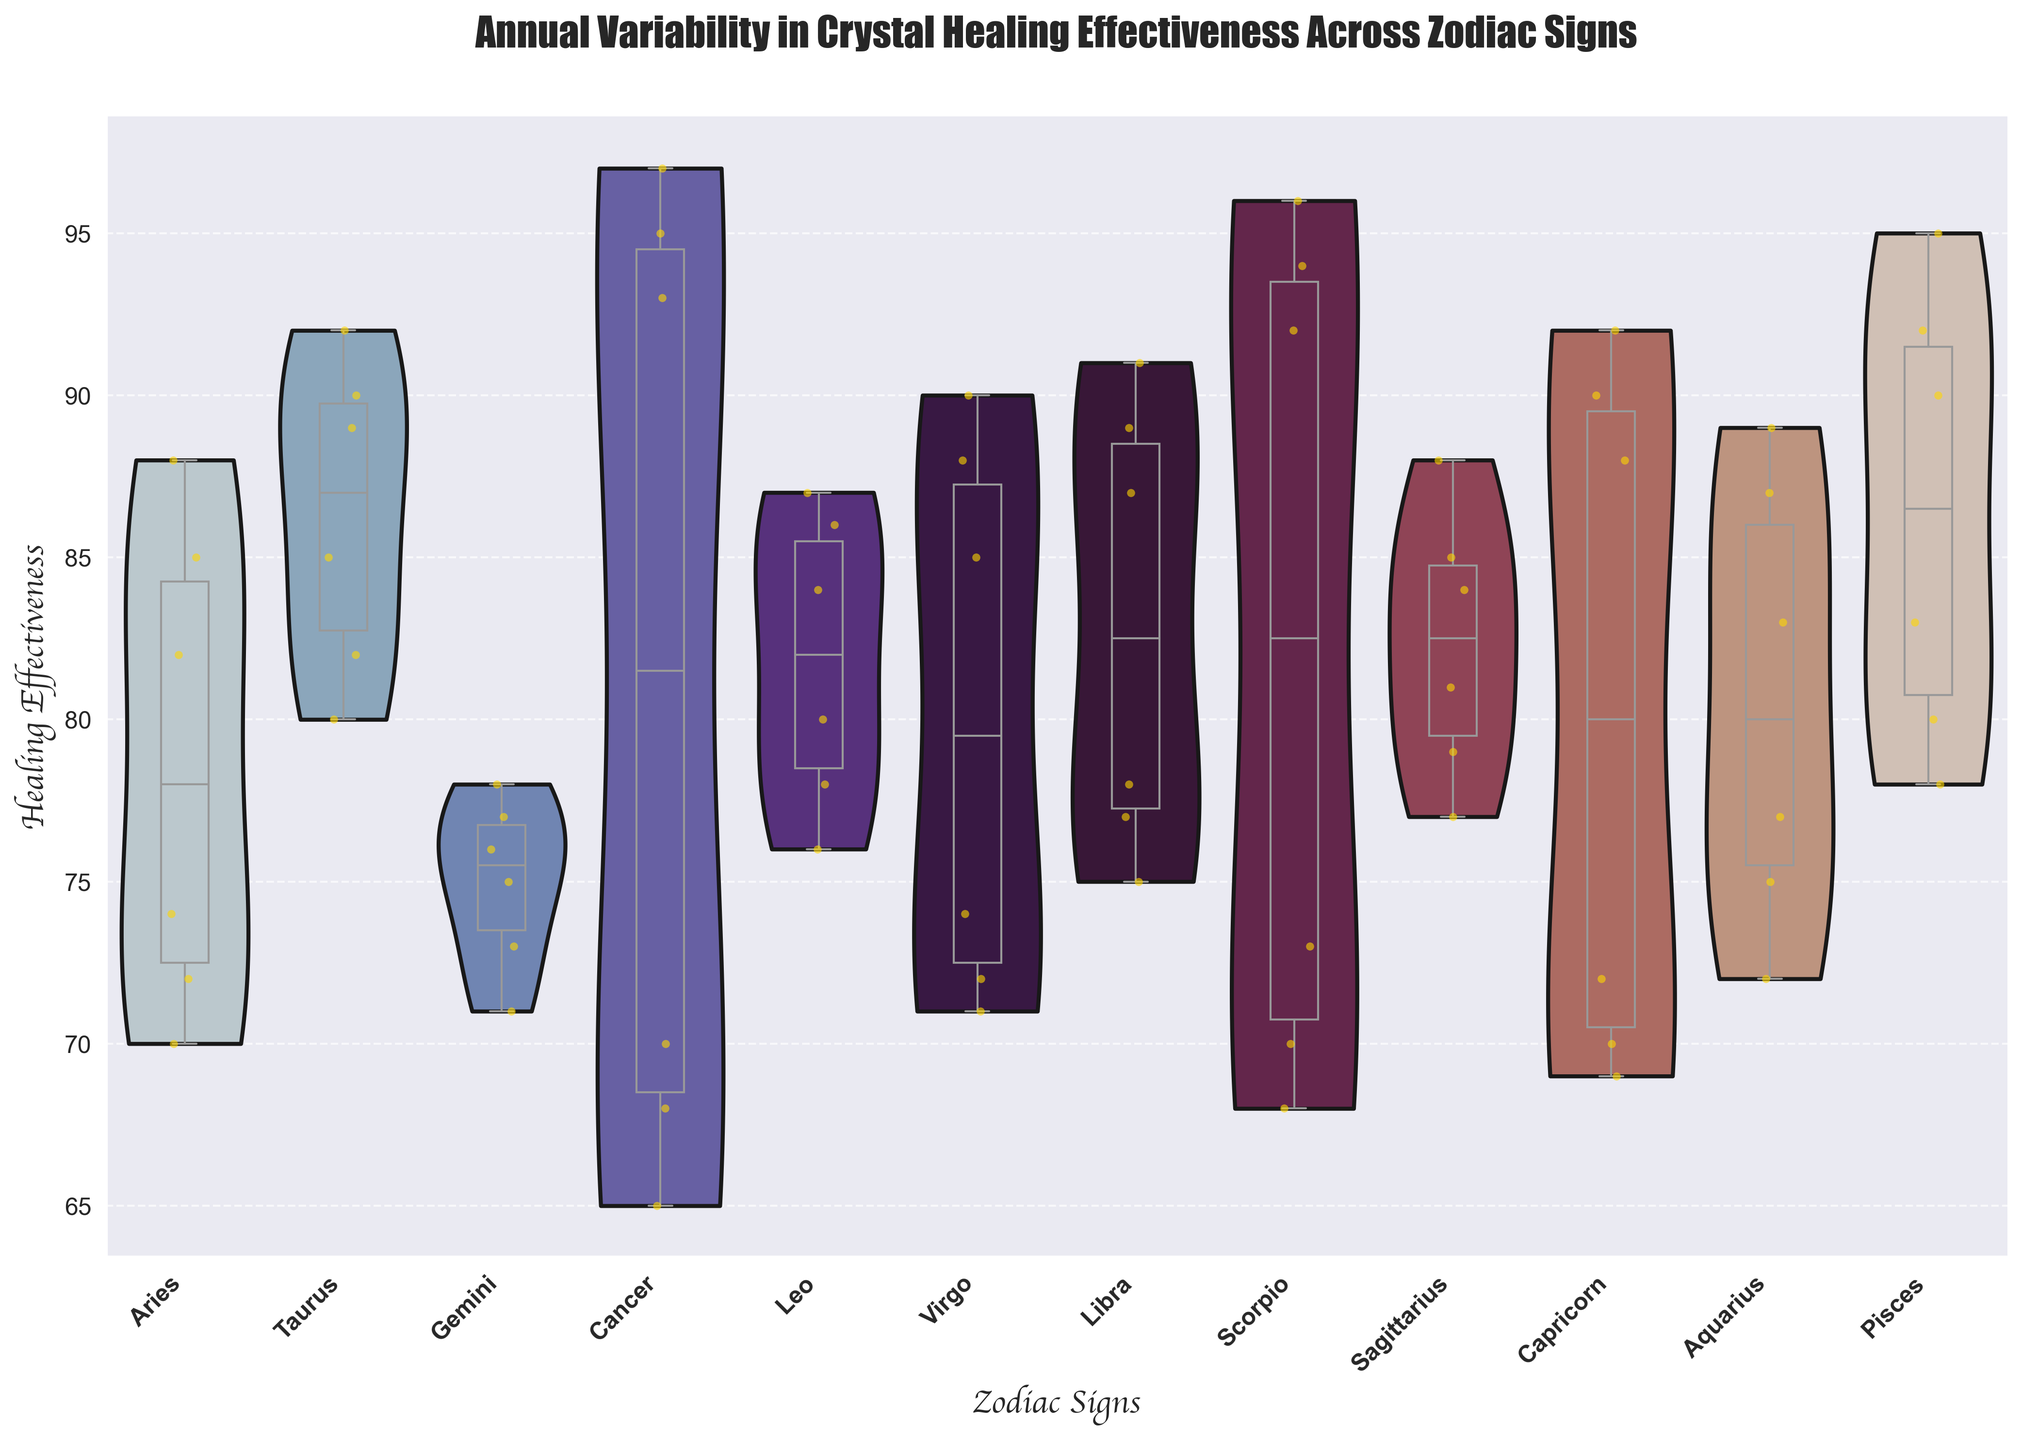What zodiac sign has the highest median healing effectiveness? The median values can be determined by looking at the center lines within each box plot overlaying the violin plots. The sign with the highest center line is Cancer.
Answer: Cancer What is the range of healing effectiveness for Leo? The range is the difference between the highest and lowest points in the violin plot for Leo. The highest point is around 87, and the lowest point is around 76, making the range 87-76=11.
Answer: 11 Are there more data points for Amethyst or Emerald under Taurus? By checking the vertical positions of data points within each box plot for Taurus, there are more data points for Amethyst (three) compared to Emerald (three), meaning they are equal in number.
Answer: Equal Which crystal type shows the highest variability in healing effectiveness for Pisces? The variability can be observed by the width of the violin plot. The Amethyst violin plot for Pisces is wider than the Rose Quartz plot, indicating higher variability.
Answer: Amethyst What is the average healing effectiveness range for Sagittarius? To find the range for Sagittarius and then average it: Amethyst ranges from 77 to 81 (range 4), and Turquoise ranges from 84 to 88 (range 4). The average of the ranges is (4+4)/2 = 4.
Answer: 4 Which zodiac sign shows the lowest minimum healing effectiveness? The lowest minimum value can be found by looking at the lowest points across all violin plots. Cancer has the lowest point, which is around 65.
Answer: Cancer How does the median healing effectiveness of Aries compare to Sagittarius? Comparing the center lines of the box plots, Aries has a median around 74, while Sagittarius has a median around 77, making Aries lower than Sagittarius.
Answer: Lower Which crystal type has the most consistent healing effectiveness for Leo? Consistency can be gauged by the narrowness of the violin plot. Carnelian has a narrower violin plot compared to Amethyst, indicating more consistency.
Answer: Carnelian 